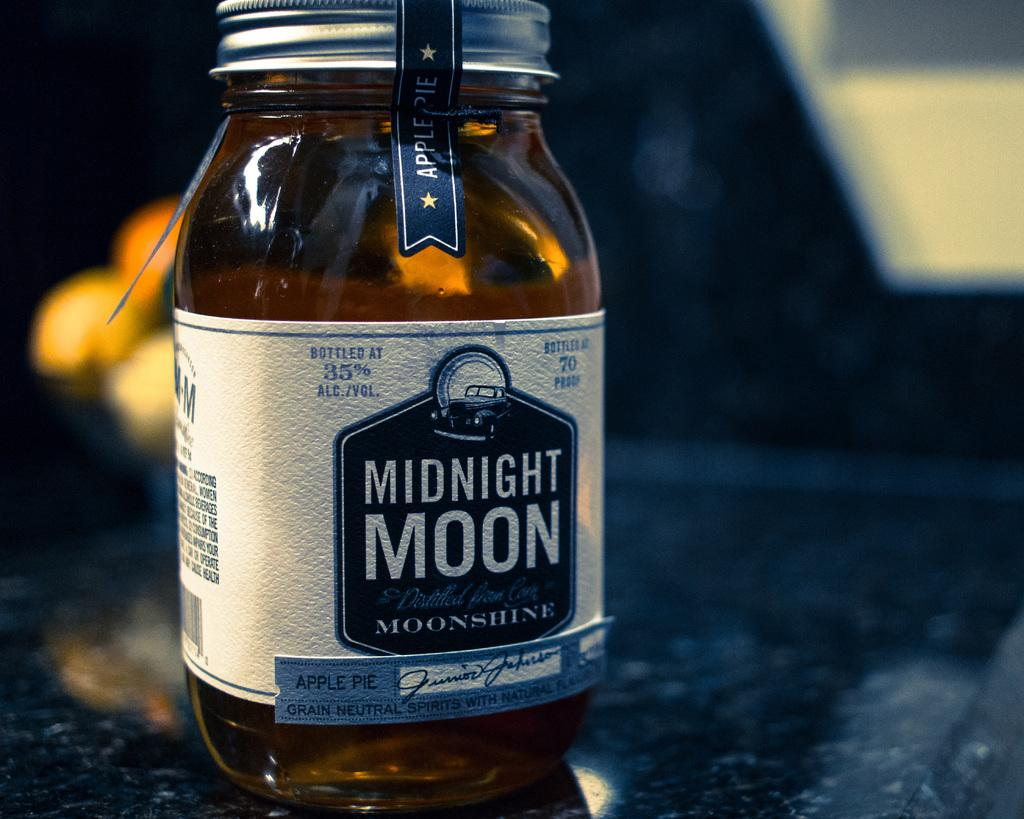<image>
Provide a brief description of the given image. Small jar of Midnight Moon moonshine on top of a marble top. 